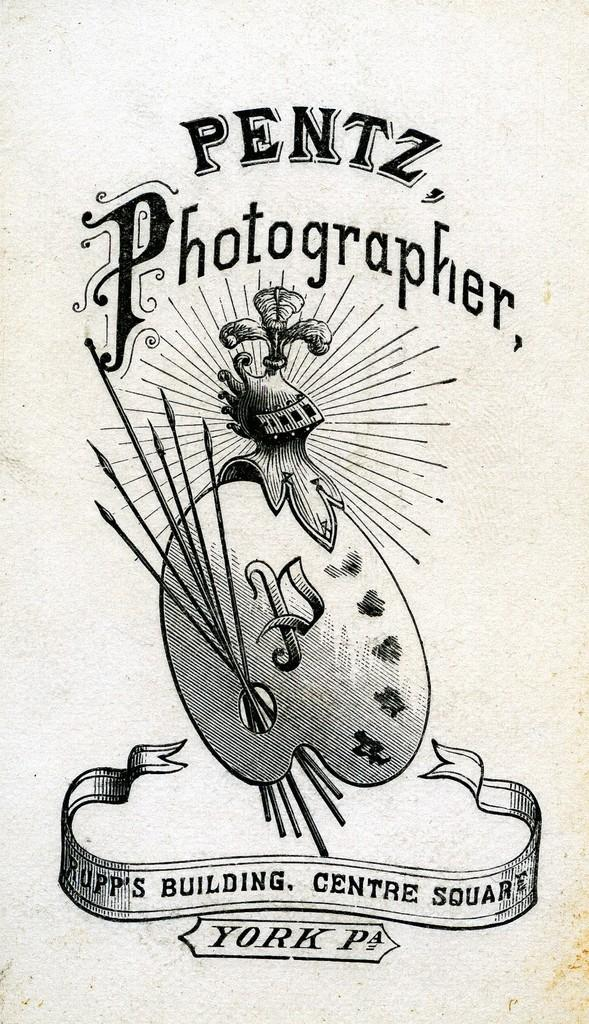What is the main subject of the image? The main subject of the image is a cover photo. What can be seen in the cover photo? There is a picture of something in the image. Are there any words or phrases in the image? Yes, there is text present in the image. Can you see a ghost wearing a crown in the image? No, there is no ghost or crown present in the image. 